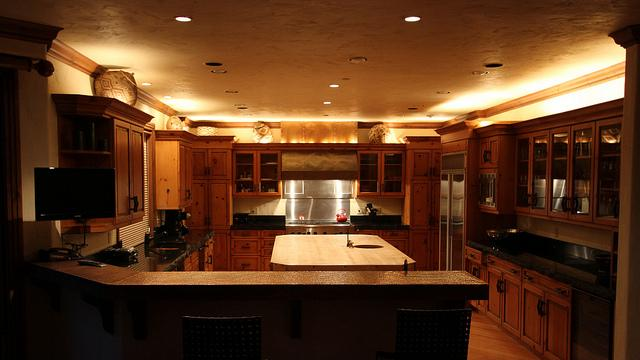What color is the water kettle on the top of the oven in the back of the kitchen? red 